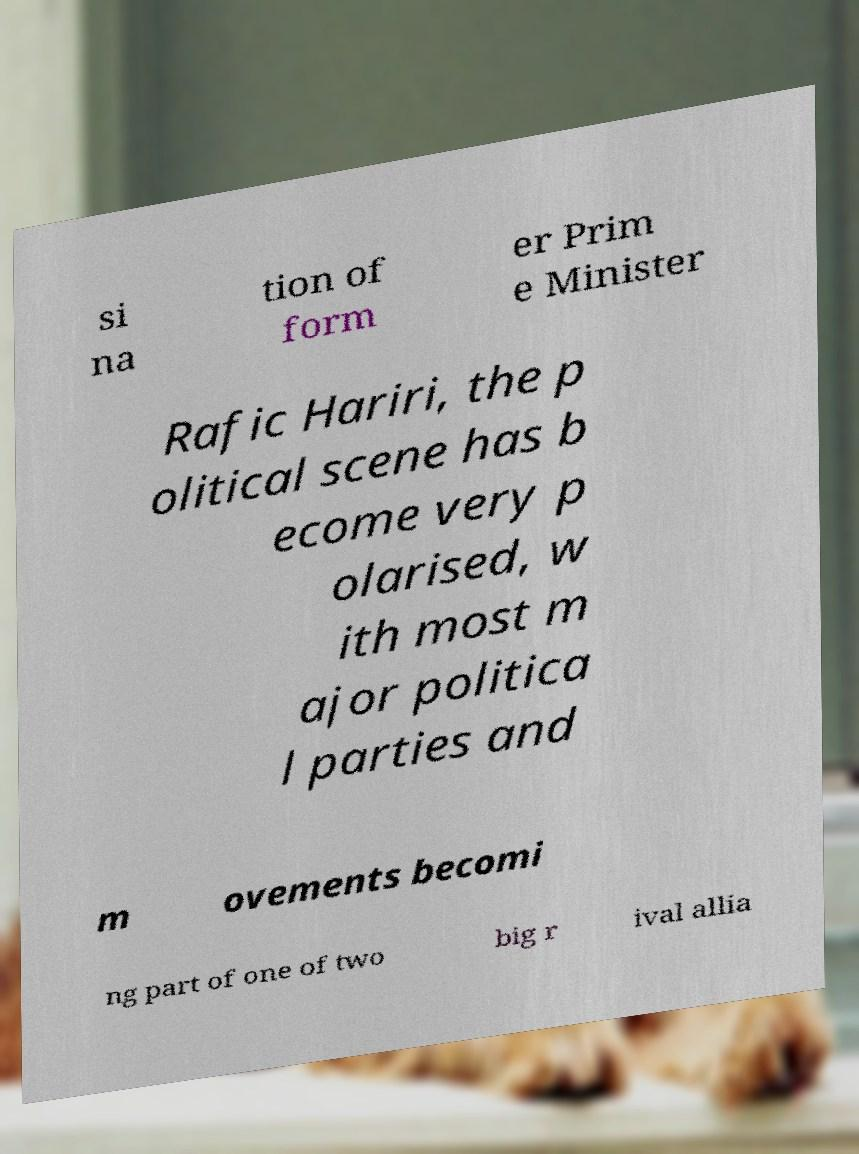There's text embedded in this image that I need extracted. Can you transcribe it verbatim? si na tion of form er Prim e Minister Rafic Hariri, the p olitical scene has b ecome very p olarised, w ith most m ajor politica l parties and m ovements becomi ng part of one of two big r ival allia 